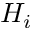<formula> <loc_0><loc_0><loc_500><loc_500>H _ { i }</formula> 